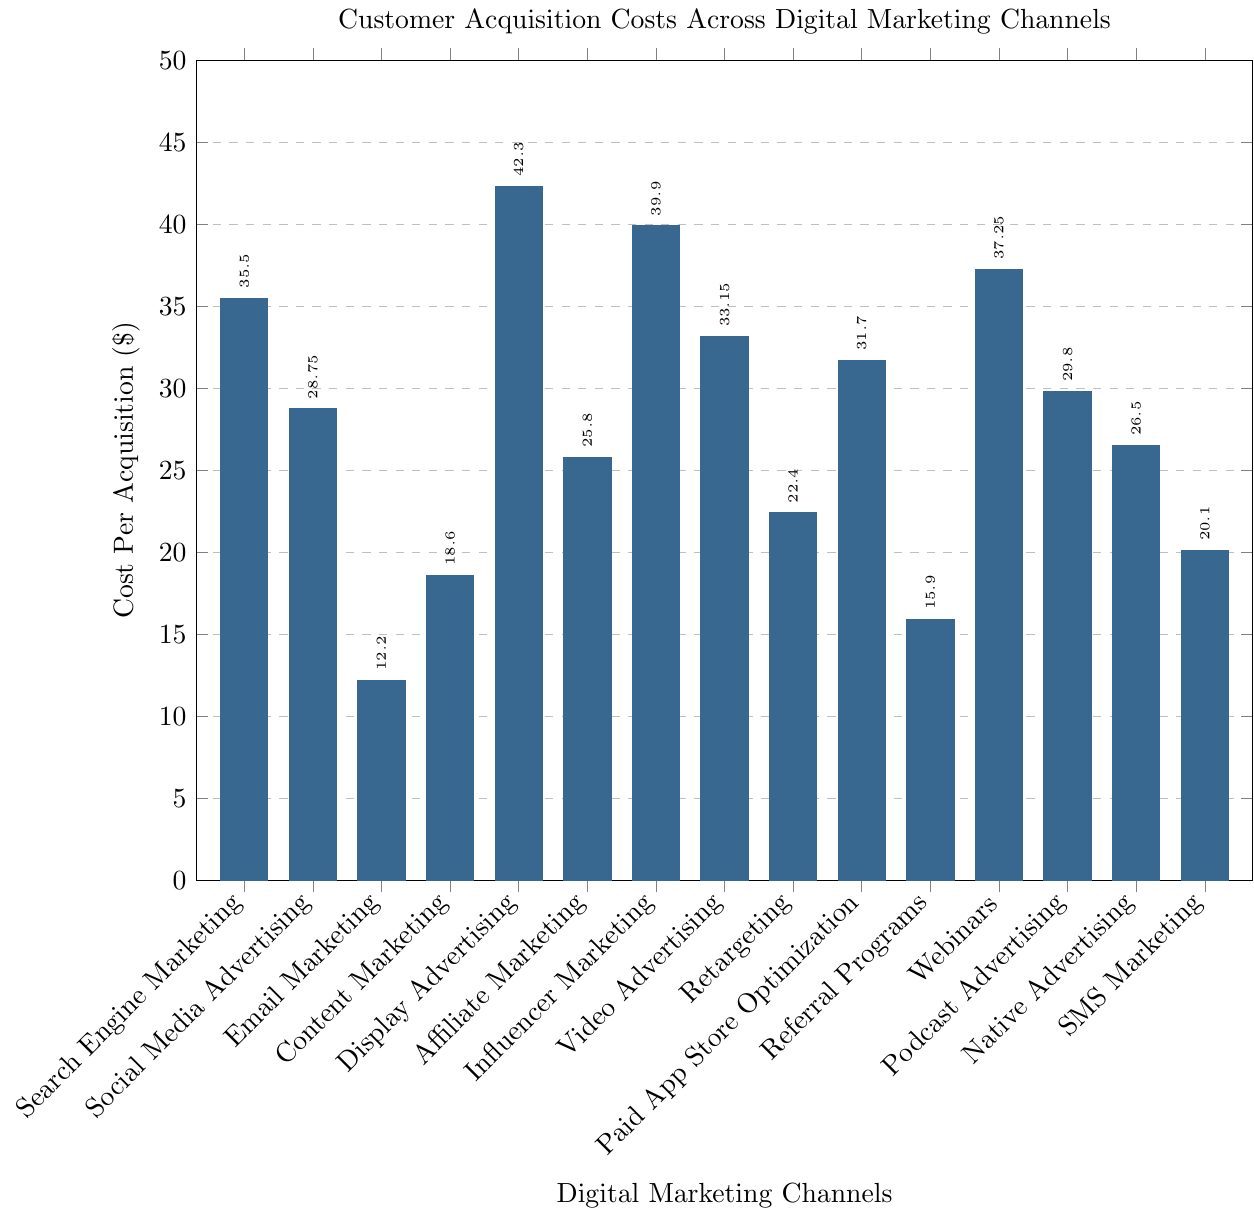Which channel has the highest cost per acquisition? By examining the heights of the bars in the chart, the bar labeled "Display Advertising" is the tallest, indicating the highest cost per acquisition.
Answer: Display Advertising Which channel has the lowest cost per acquisition? By examining the heights of the bars in the chart, the shortest bar is labeled "Email Marketing," indicating that it has the lowest cost per acquisition.
Answer: Email Marketing What is the cost difference between Search Engine Marketing and Social Media Advertising? From the chart, the cost per acquisition for Search Engine Marketing is $35.50 and for Social Media Advertising is $28.75. The difference is calculated as $35.50 - $28.75.
Answer: $6.75 How many channels have a cost per acquisition higher than $30? By visually scanning the heights of the bars, count the bars that are above the $30 mark. The channels with costs higher than $30 are Search Engine Marketing, Display Advertising, Influencer Marketing, Video Advertising, Paid App Store Optimization, Webinars, and Podcast Advertising.
Answer: 7 What is the average cost per acquisition for the channels: Email Marketing, Content Marketing, and Display Advertising? Extract the costs from the chart: Email Marketing ($12.20), Content Marketing ($18.60), and Display Advertising ($42.30). Sum these values: $12.20 + $18.60 + $42.30 = $73.10. Divide by 3 (the number of channels): $73.10 / 3 = $24.37.
Answer: $24.37 Which two channels have the closest cost per acquisition? By comparing all the bars in the chart, the costs of Podcast Advertising ($29.80) and Social Media Advertising ($28.75) are the closest to each other. The difference is $29.80 - $28.75 = $1.05.
Answer: Podcast Advertising and Social Media Advertising What is the median cost per acquisition across all channels? List all costs: [$12.20, $15.90, $18.60, $20.10, $22.40, $25.80, $26.50, $28.75, $29.80, $31.70, $33.15, $35.50, $37.25, $39.90, $42.30]. There are 15 values, so the median is the 8th value in the ordered list.
Answer: $28.75 Compare the costs of Video Advertising and Webinars. Which is greater? By how much? The cost per acquisition for Video Advertising is $33.15 and for Webinars is $37.25. Webinars cost more. The difference is $37.25 - $33.15.
Answer: Webinars by $4.10 